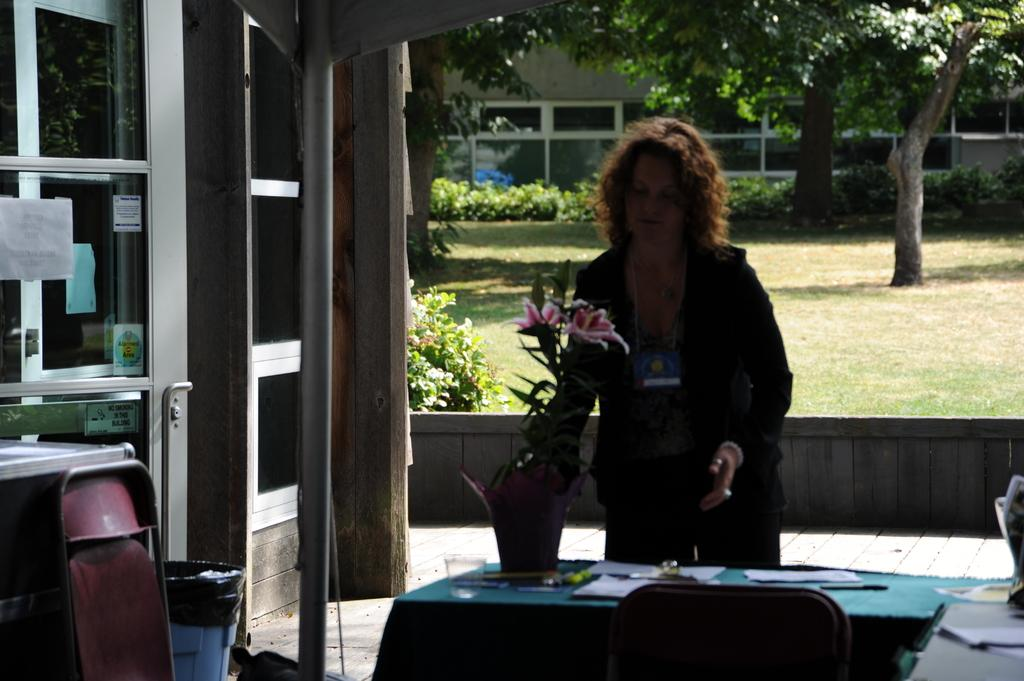What is the woman doing in the image? There is a woman standing in the image. What is in front of the woman? There is a pot in front of the woman. What piece of furniture is present in the image? There is a table in the image. What can be seen behind the woman? There is a garden visible behind the woman. What types of vegetation are present in the garden? The garden contains trees, plants, and grass. How many fingers does the woman have on her left hand in the image? The image does not provide enough detail to determine the number of fingers on the woman's left hand. What is the woman learning in the image? There is no indication in the image that the woman is learning anything. 